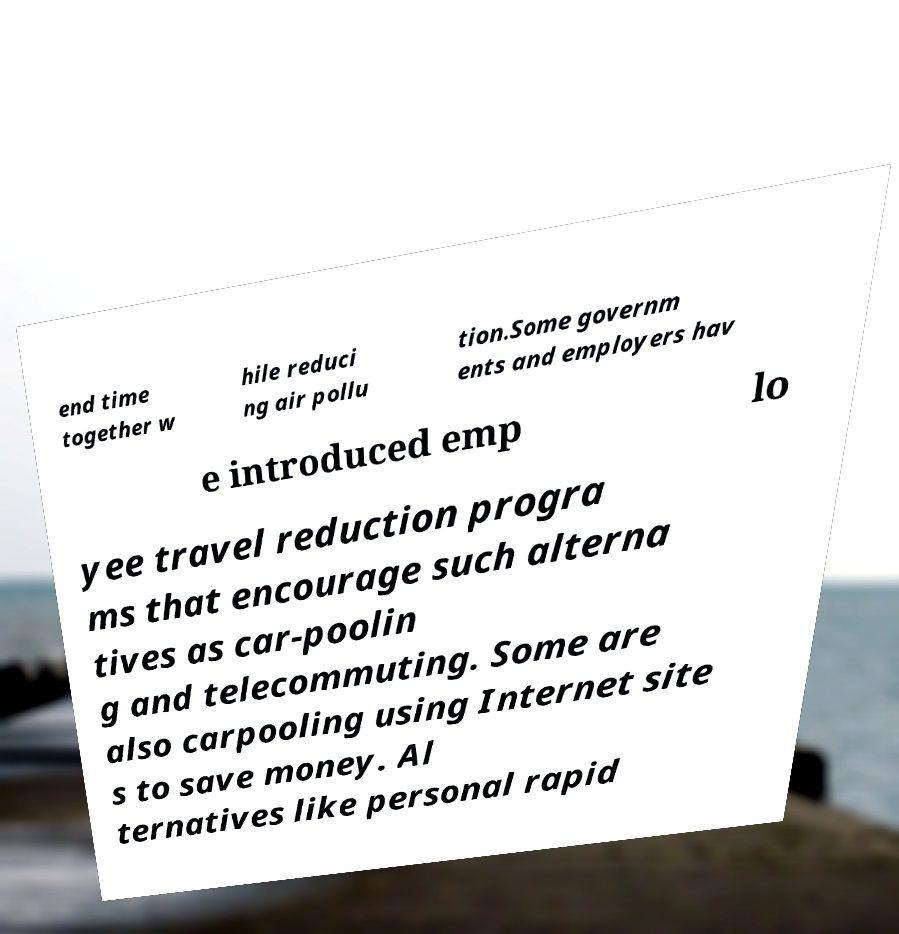For documentation purposes, I need the text within this image transcribed. Could you provide that? end time together w hile reduci ng air pollu tion.Some governm ents and employers hav e introduced emp lo yee travel reduction progra ms that encourage such alterna tives as car-poolin g and telecommuting. Some are also carpooling using Internet site s to save money. Al ternatives like personal rapid 